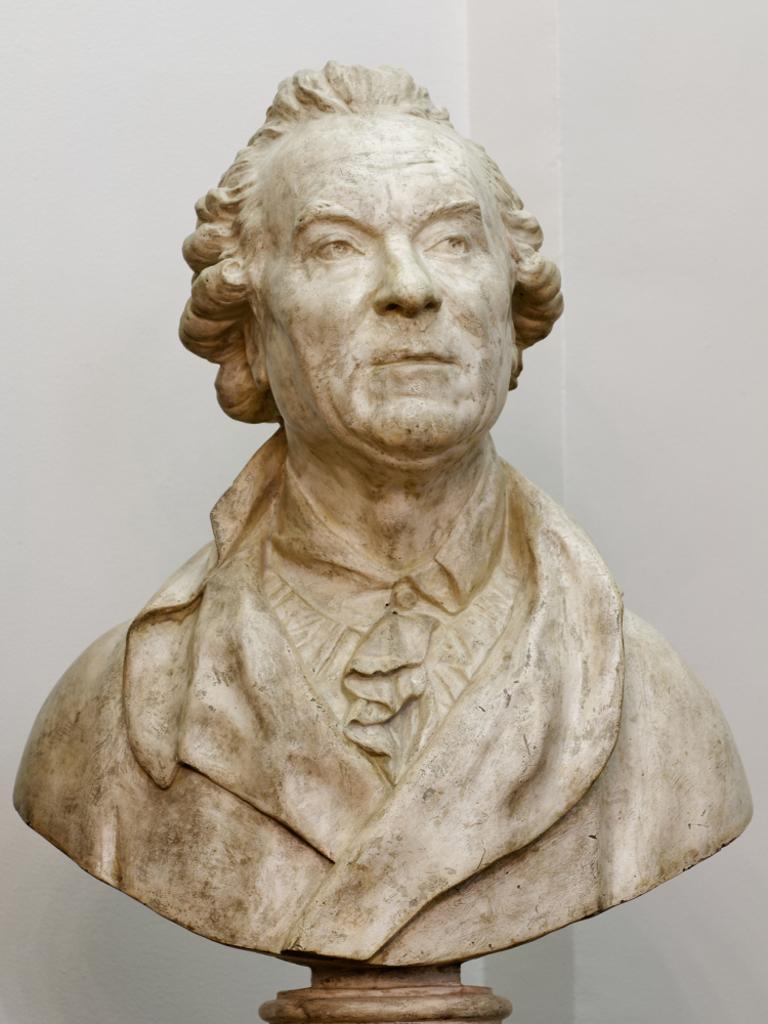Please provide a concise description of this image. In this image we can see the depiction of a man. In the background there is a plain wall. 